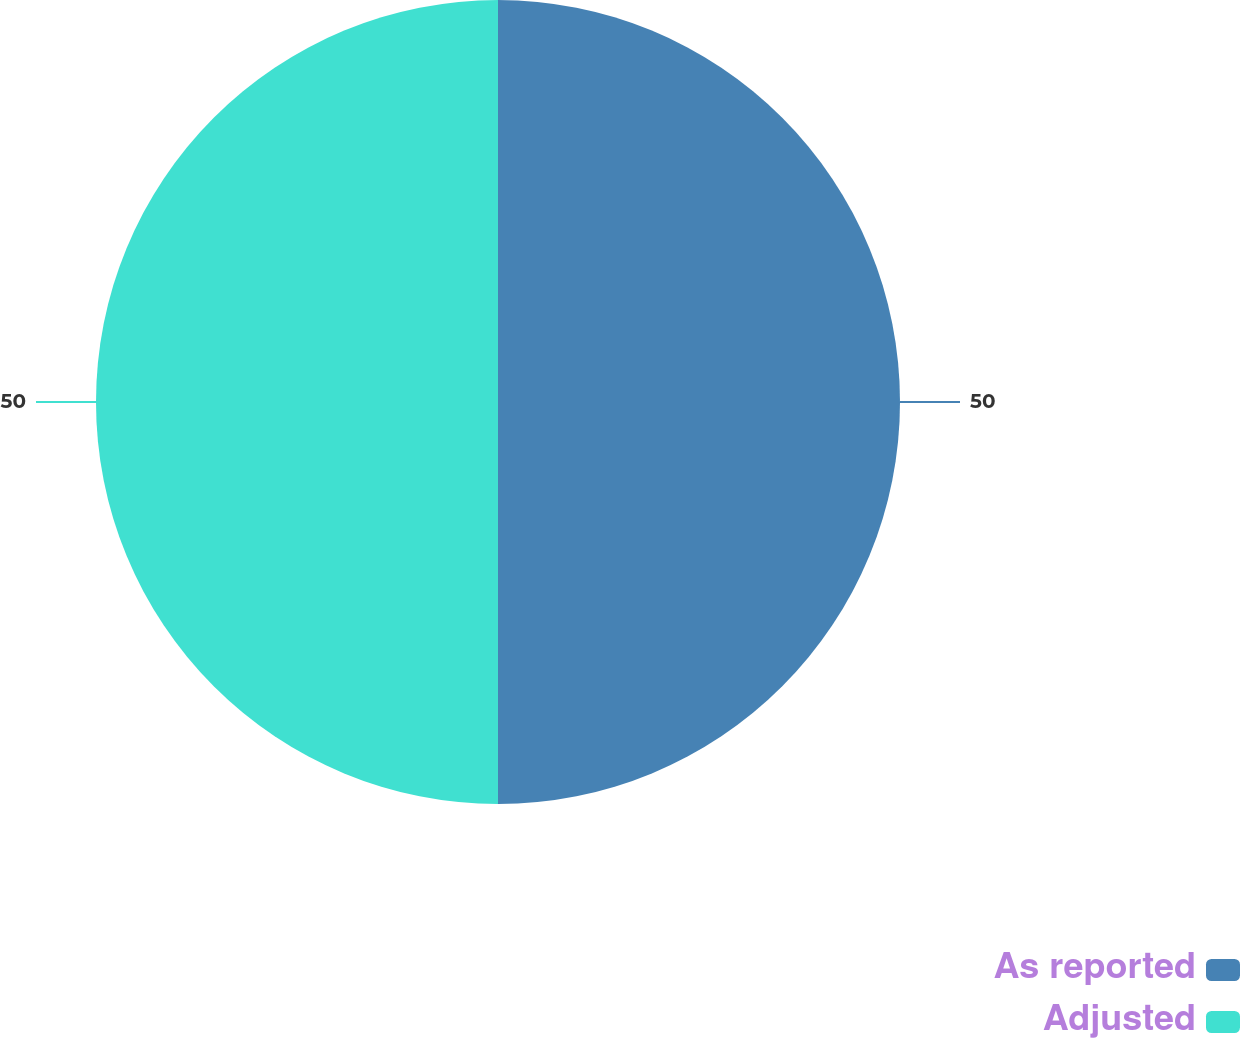Convert chart to OTSL. <chart><loc_0><loc_0><loc_500><loc_500><pie_chart><fcel>As reported<fcel>Adjusted<nl><fcel>50.0%<fcel>50.0%<nl></chart> 